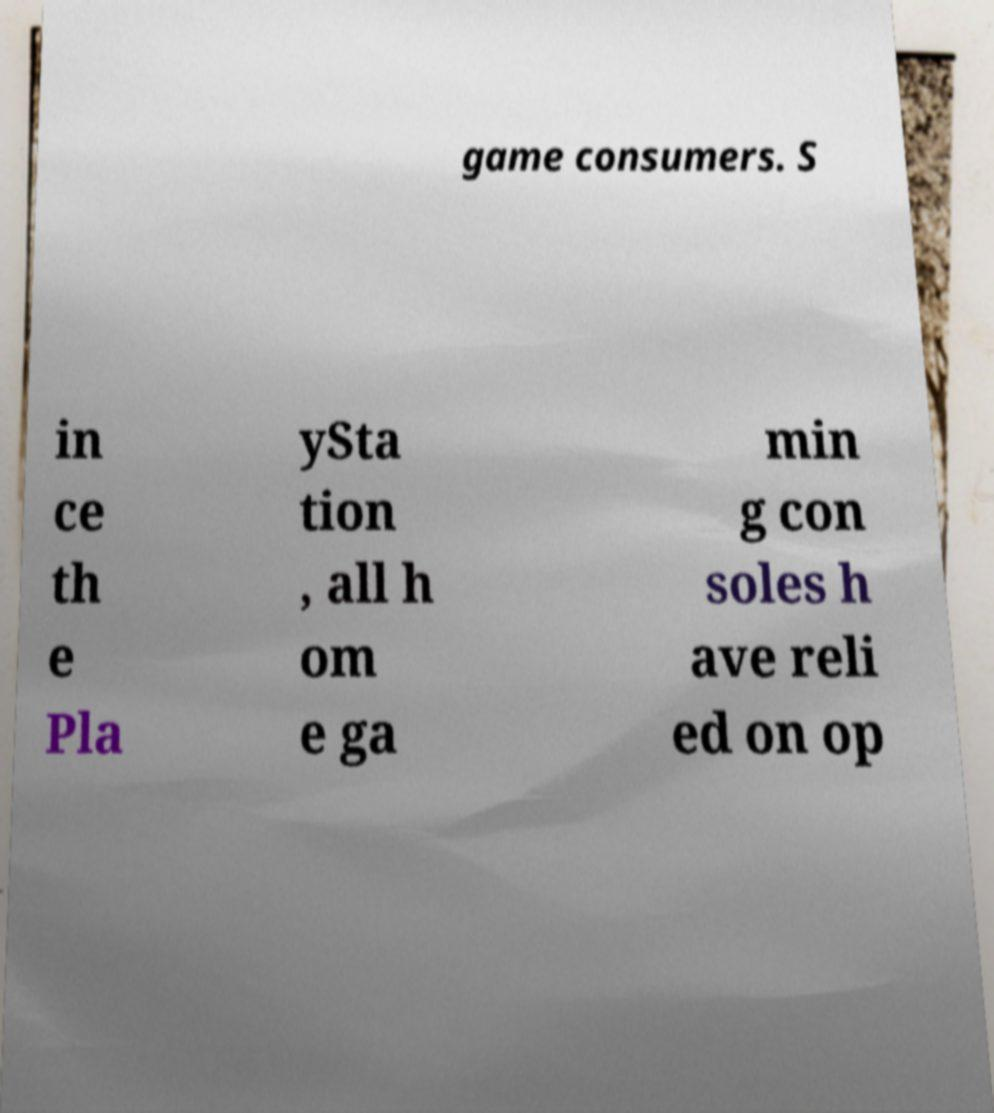There's text embedded in this image that I need extracted. Can you transcribe it verbatim? game consumers. S in ce th e Pla ySta tion , all h om e ga min g con soles h ave reli ed on op 